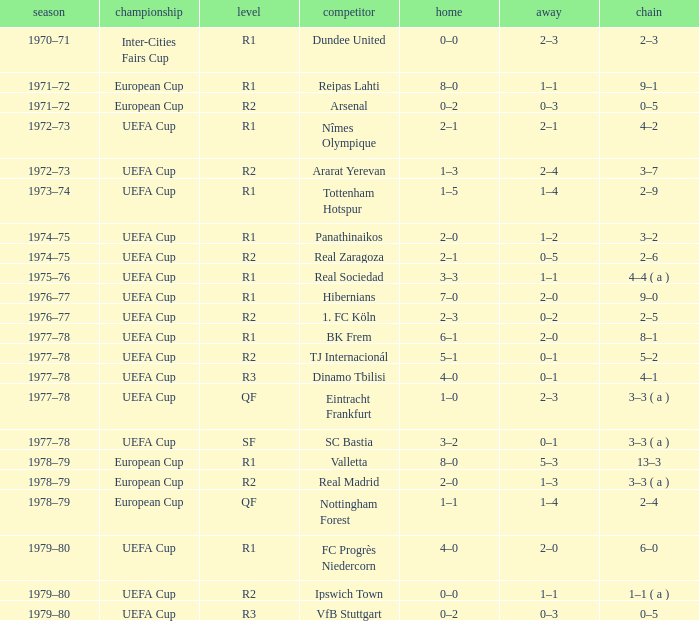Which Round has a Competition of uefa cup, and a Series of 5–2? R2. 